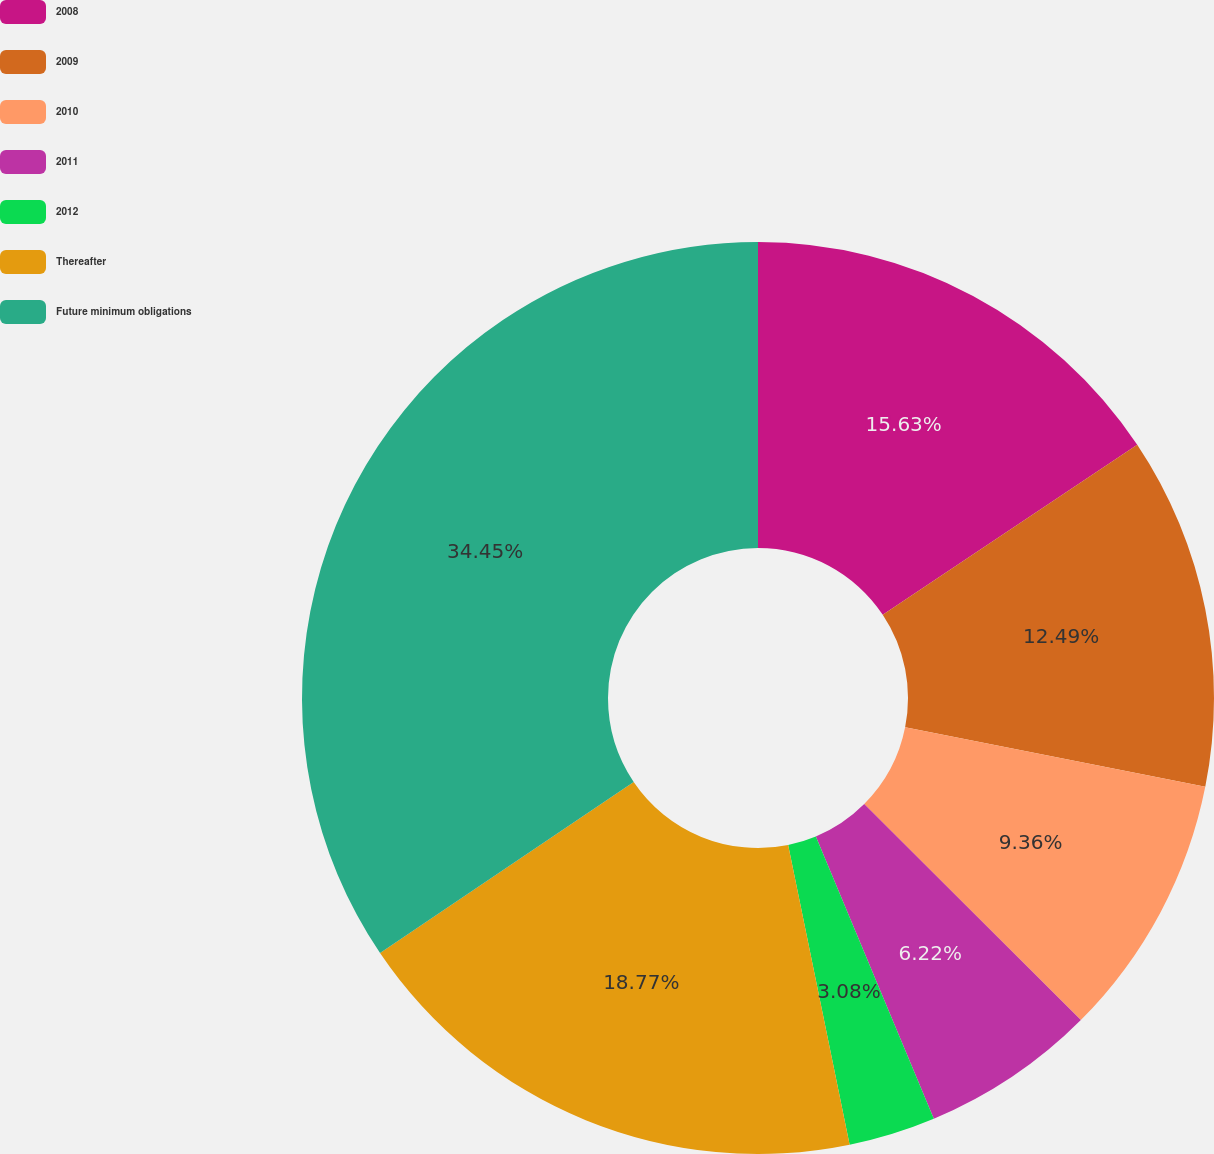<chart> <loc_0><loc_0><loc_500><loc_500><pie_chart><fcel>2008<fcel>2009<fcel>2010<fcel>2011<fcel>2012<fcel>Thereafter<fcel>Future minimum obligations<nl><fcel>15.63%<fcel>12.49%<fcel>9.36%<fcel>6.22%<fcel>3.08%<fcel>18.77%<fcel>34.45%<nl></chart> 